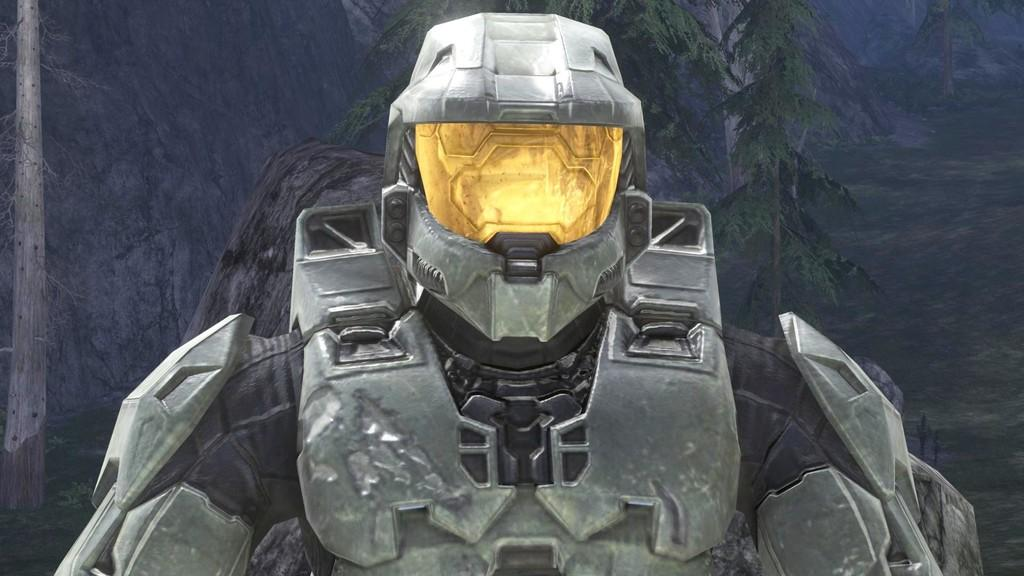What is the main subject of the image? There is a robot in the image. What can be seen in the background of the image? There is a painting of trees in the background of the image. What type of cup is being held by the robot in the image? There is no cup present in the image; the robot is not holding anything. 